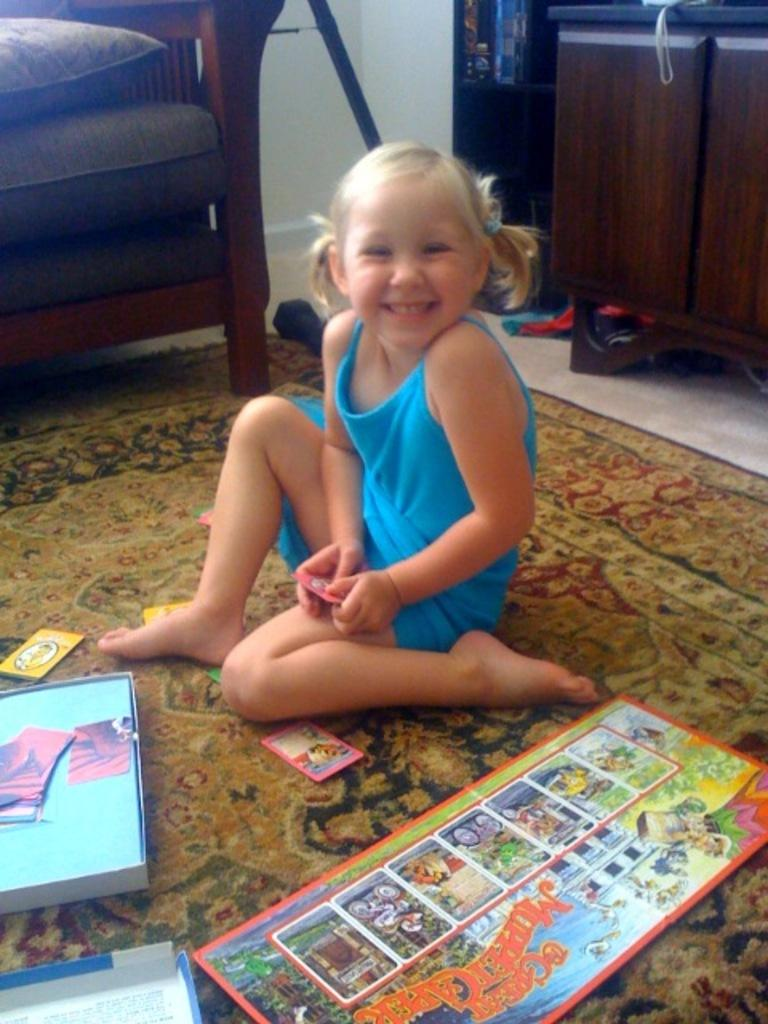What is the girl in the image doing? The girl is sitting on the floor mat. What is the girl wearing in the image? The girl is wearing a blue dress. What objects can be seen at the bottom of the image? There are books at the bottom of the image. What type of furniture is visible at the top of the image? There appears to be a sofa at the top of the image. How many spiders are crawling on the girl's dress in the image? There are no spiders present in the image. What type of table is visible in the image? There is no table visible in the image. 